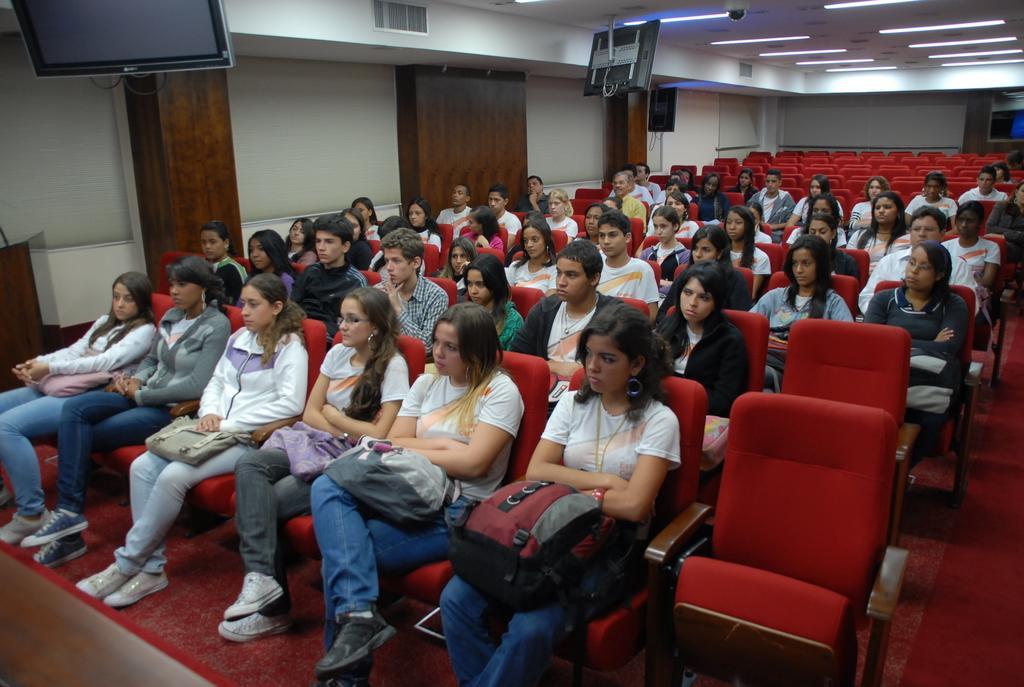How would you summarize this image in a sentence or two? In this image we can see a group of people sitting on chairs. Among them few people are holding bags. Behind the persons we can see the wall. At the top we can see the roof, lights and televisions. 